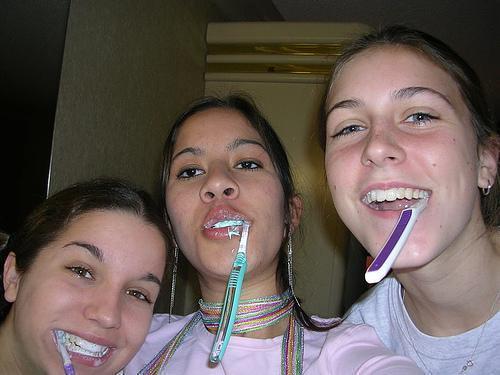What color is the toothbrush in the mouth of the woman in the center?
Indicate the correct choice and explain in the format: 'Answer: answer
Rationale: rationale.'
Options: Purple, turquoise, red, pink. Answer: turquoise.
Rationale: It's a lighter blue green color 